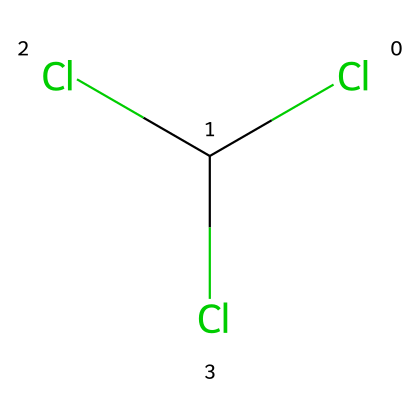How many chlorine atoms are present in this chemical? The SMILES representation shows "Cl" three times. Each "Cl" denotes one chlorine atom. Therefore, there are three chlorine atoms.
Answer: three What is the molecular formula of this compound? In the SMILES, we have three chlorine atoms and one carbon atom. Thus, the molecular formula can be represented as CCl3.
Answer: CCl3 What type of chemical bonding is primarily observed in this compound? The presence of multiple chlorine atoms bonded to a single carbon atom suggests the chemical primarily exhibits covalent bonding, as carbon shares electrons with chlorine atoms.
Answer: covalent What is the common use of this chemical in historical contexts? Historically, chloroform has been used as an anesthetic and in espionage for its ability to induce unconsciousness.
Answer: espionage Why might this chemical be considered hazardous? Chloroform is considered hazardous due to its potential toxicity and harmful effects, particularly when inhaled or ingested, leading to risks such as liver damage or anesthetic complications.
Answer: toxic Is this compound a polar or nonpolar solvent? The structure, with a carbon atom bonded to three electronegative chlorine atoms, suggests an asymmetrical distribution of charge, indicating that it is a polar solvent.
Answer: polar 